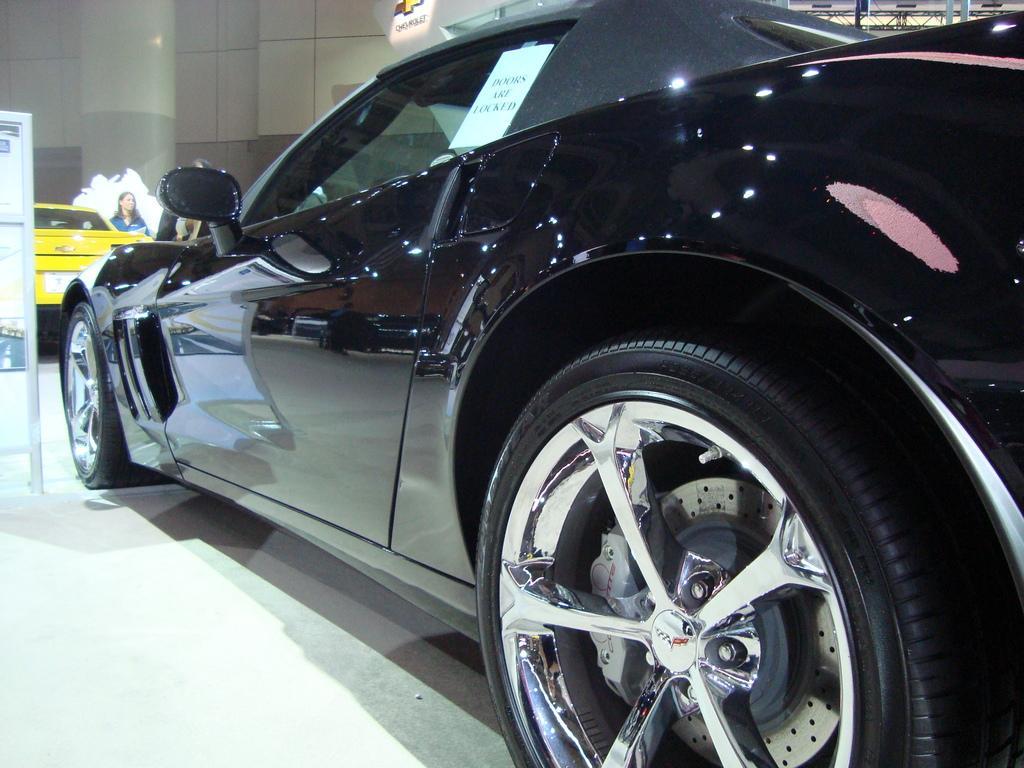Please provide a concise description of this image. In this image there are vehicles parked on the floor. In the foreground there is a car. There is a paper on the car. To the left there is a board. Behind the car there is a woman standing. In the background there is a wall. 